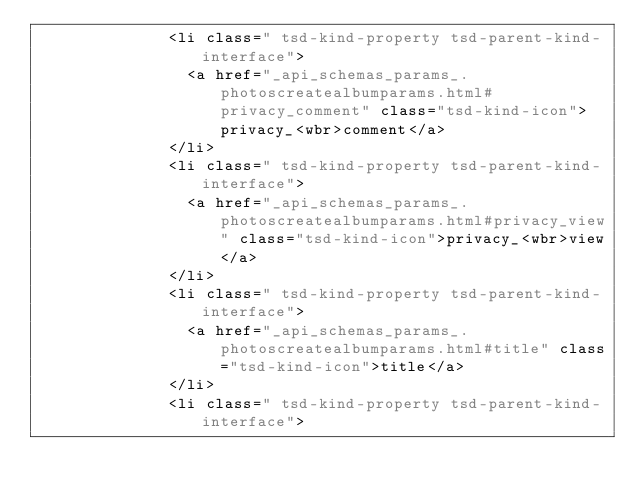<code> <loc_0><loc_0><loc_500><loc_500><_HTML_>							<li class=" tsd-kind-property tsd-parent-kind-interface">
								<a href="_api_schemas_params_.photoscreatealbumparams.html#privacy_comment" class="tsd-kind-icon">privacy_<wbr>comment</a>
							</li>
							<li class=" tsd-kind-property tsd-parent-kind-interface">
								<a href="_api_schemas_params_.photoscreatealbumparams.html#privacy_view" class="tsd-kind-icon">privacy_<wbr>view</a>
							</li>
							<li class=" tsd-kind-property tsd-parent-kind-interface">
								<a href="_api_schemas_params_.photoscreatealbumparams.html#title" class="tsd-kind-icon">title</a>
							</li>
							<li class=" tsd-kind-property tsd-parent-kind-interface"></code> 